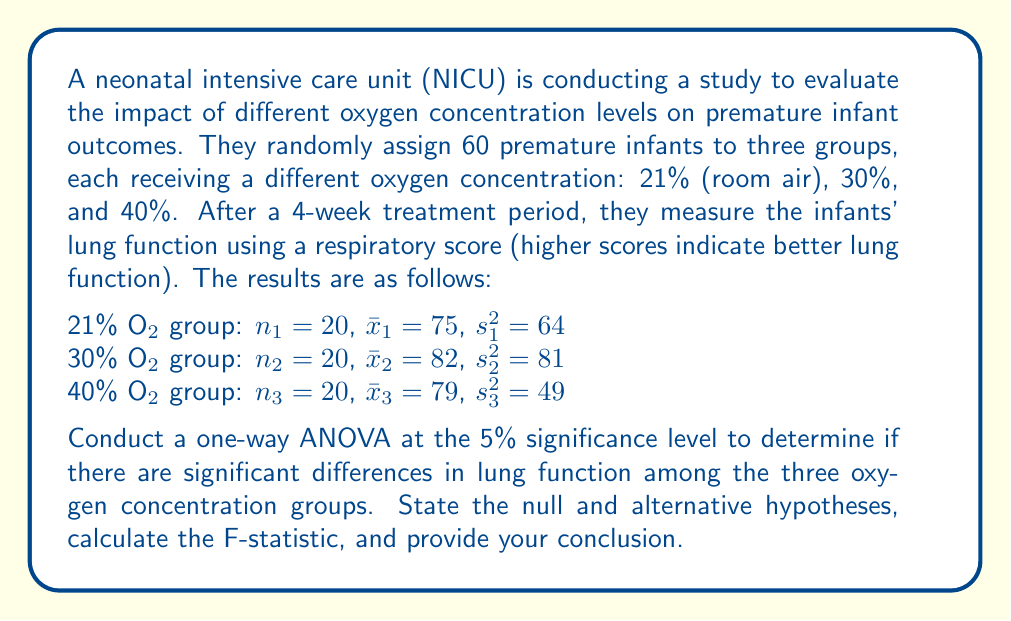Teach me how to tackle this problem. Let's approach this step-by-step:

1) First, state the null and alternative hypotheses:
   $H_0: \mu_1 = \mu_2 = \mu_3$ (all group means are equal)
   $H_1:$ At least one group mean is different

2) Calculate the total sum of squares (SST):
   $$SST = \sum_{i=1}^{3} (n_i - 1)s_i^2 + \sum_{i=1}^{3} n_i(\bar{x}_i - \bar{x})^2$$
   
   Where $\bar{x}$ is the grand mean:
   $$\bar{x} = \frac{20(75) + 20(82) + 20(79)}{60} = 78.67$$

   $$SST = 19(64) + 19(81) + 19(49) + 20(75-78.67)^2 + 20(82-78.67)^2 + 20(79-78.67)^2$$
   $$SST = 1216 + 1539 + 931 + 268.45 + 222.45 + 2.45 = 4179.35$$

3) Calculate the between-group sum of squares (SSB):
   $$SSB = \sum_{i=1}^{3} n_i(\bar{x}_i - \bar{x})^2 = 268.45 + 222.45 + 2.45 = 493.35$$

4) Calculate the within-group sum of squares (SSW):
   $$SSW = SST - SSB = 4179.35 - 493.35 = 3686$$

5) Calculate degrees of freedom:
   $df_{between} = k - 1 = 3 - 1 = 2$ (where k is the number of groups)
   $df_{within} = N - k = 60 - 3 = 57$ (where N is the total sample size)

6) Calculate mean squares:
   $$MSB = \frac{SSB}{df_{between}} = \frac{493.35}{2} = 246.675$$
   $$MSW = \frac{SSW}{df_{within}} = \frac{3686}{57} = 64.667$$

7) Calculate the F-statistic:
   $$F = \frac{MSB}{MSW} = \frac{246.675}{64.667} = 3.815$$

8) Find the critical F-value:
   For $\alpha = 0.05$, $df_{between} = 2$, and $df_{within} = 57$, the critical F-value is approximately 3.159.

9) Make a decision:
   Since the calculated F-statistic (3.815) is greater than the critical F-value (3.159), we reject the null hypothesis.
Answer: Reject the null hypothesis. There is sufficient evidence to conclude that there are significant differences in lung function among the three oxygen concentration groups (F = 3.815, p < 0.05). 